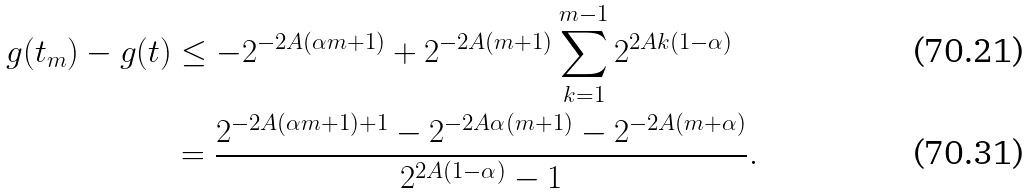Convert formula to latex. <formula><loc_0><loc_0><loc_500><loc_500>g ( t _ { m } ) - g ( t ) & \leq - 2 ^ { - 2 A ( \alpha m + 1 ) } + 2 ^ { - 2 A ( m + 1 ) } \sum _ { k = 1 } ^ { m - 1 } 2 ^ { 2 A k ( 1 - \alpha ) } \\ & = \frac { 2 ^ { - 2 A ( \alpha m + 1 ) + 1 } - 2 ^ { - 2 A \alpha ( m + 1 ) } - 2 ^ { - 2 A ( m + \alpha ) } } { 2 ^ { 2 A ( 1 - \alpha ) } - 1 } .</formula> 